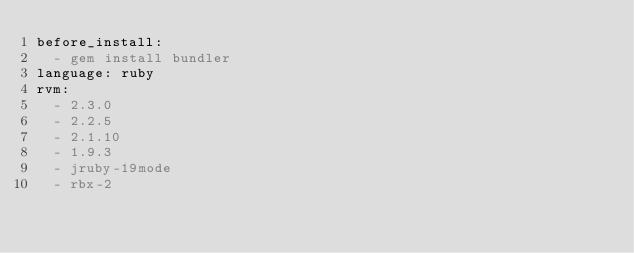Convert code to text. <code><loc_0><loc_0><loc_500><loc_500><_YAML_>before_install:
  - gem install bundler
language: ruby
rvm:
  - 2.3.0
  - 2.2.5
  - 2.1.10
  - 1.9.3
  - jruby-19mode
  - rbx-2
</code> 